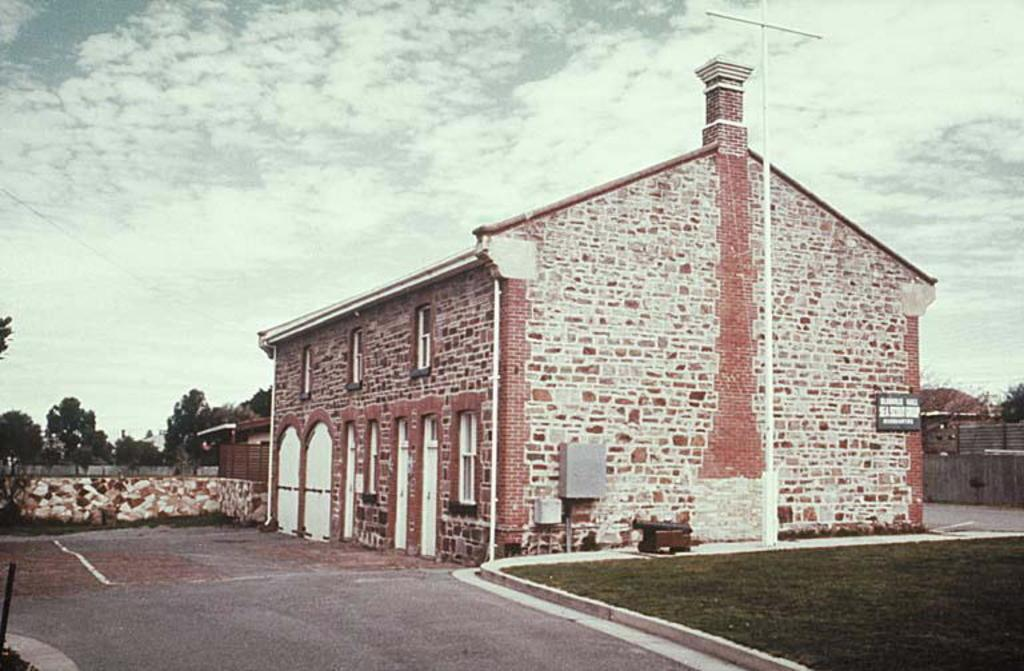What type of ground surface is visible in the image? There is grass on the ground in the image. What object can be seen standing upright in the image? There is a pole in the image. What is attached to the building in the image? There is a board on a building in the image. What can be seen in the distance behind the main subjects in the image? There is a wall and trees visible in the background of the image. How would you describe the weather based on the image? The sky is cloudy in the image, suggesting a potentially overcast or cloudy day. What type of prose is written on the board in the image? There is no prose visible on the board in the image; it is not mentioned in the provided facts. How does the error in the image affect the overall message? There is no error mentioned in the provided facts, so it is not possible to determine how it might affect the overall message. 